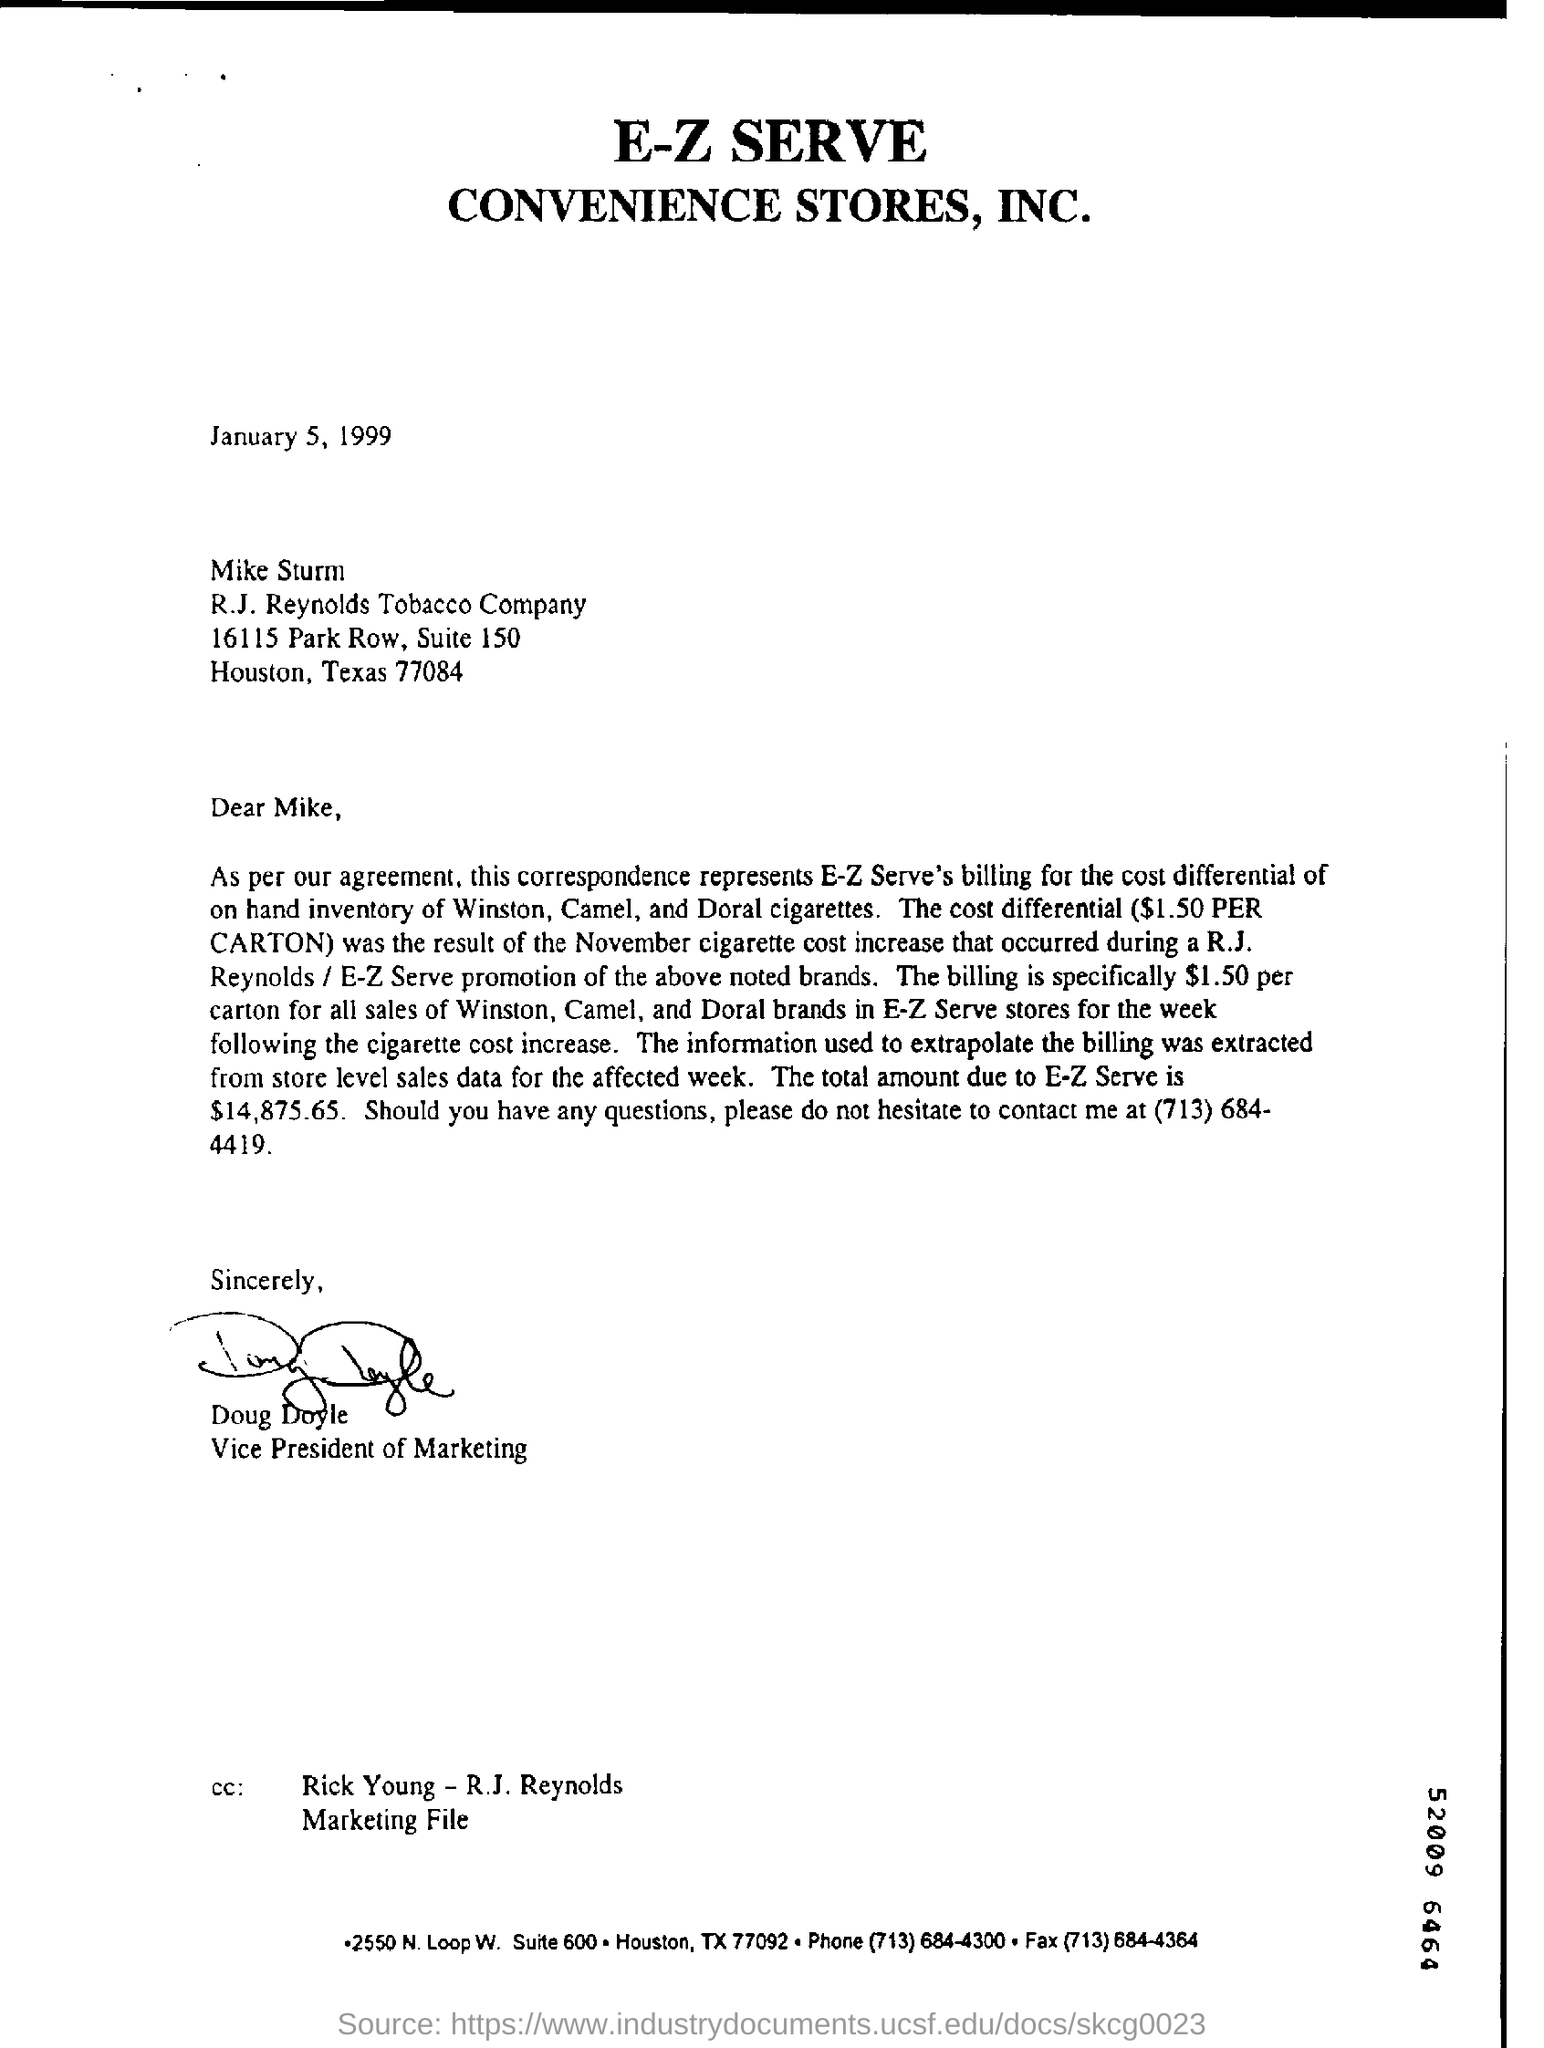Give some essential details in this illustration. I have signed the letter. Doug Doyle holds the designation of Vice President of Marketing. The date of this letter is January 5, 1999. The total amount due to E-Z Serve is $14,875.65. The addressee of this letter is Mike Sturm. 